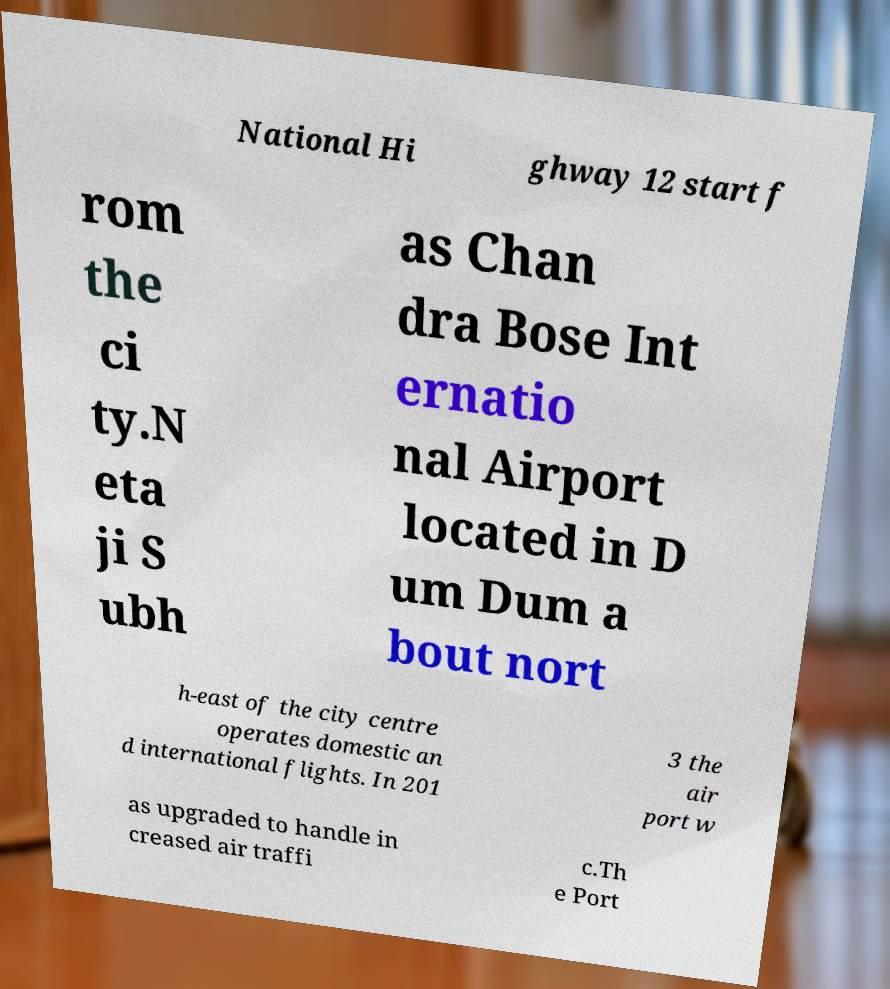Please read and relay the text visible in this image. What does it say? National Hi ghway 12 start f rom the ci ty.N eta ji S ubh as Chan dra Bose Int ernatio nal Airport located in D um Dum a bout nort h-east of the city centre operates domestic an d international flights. In 201 3 the air port w as upgraded to handle in creased air traffi c.Th e Port 